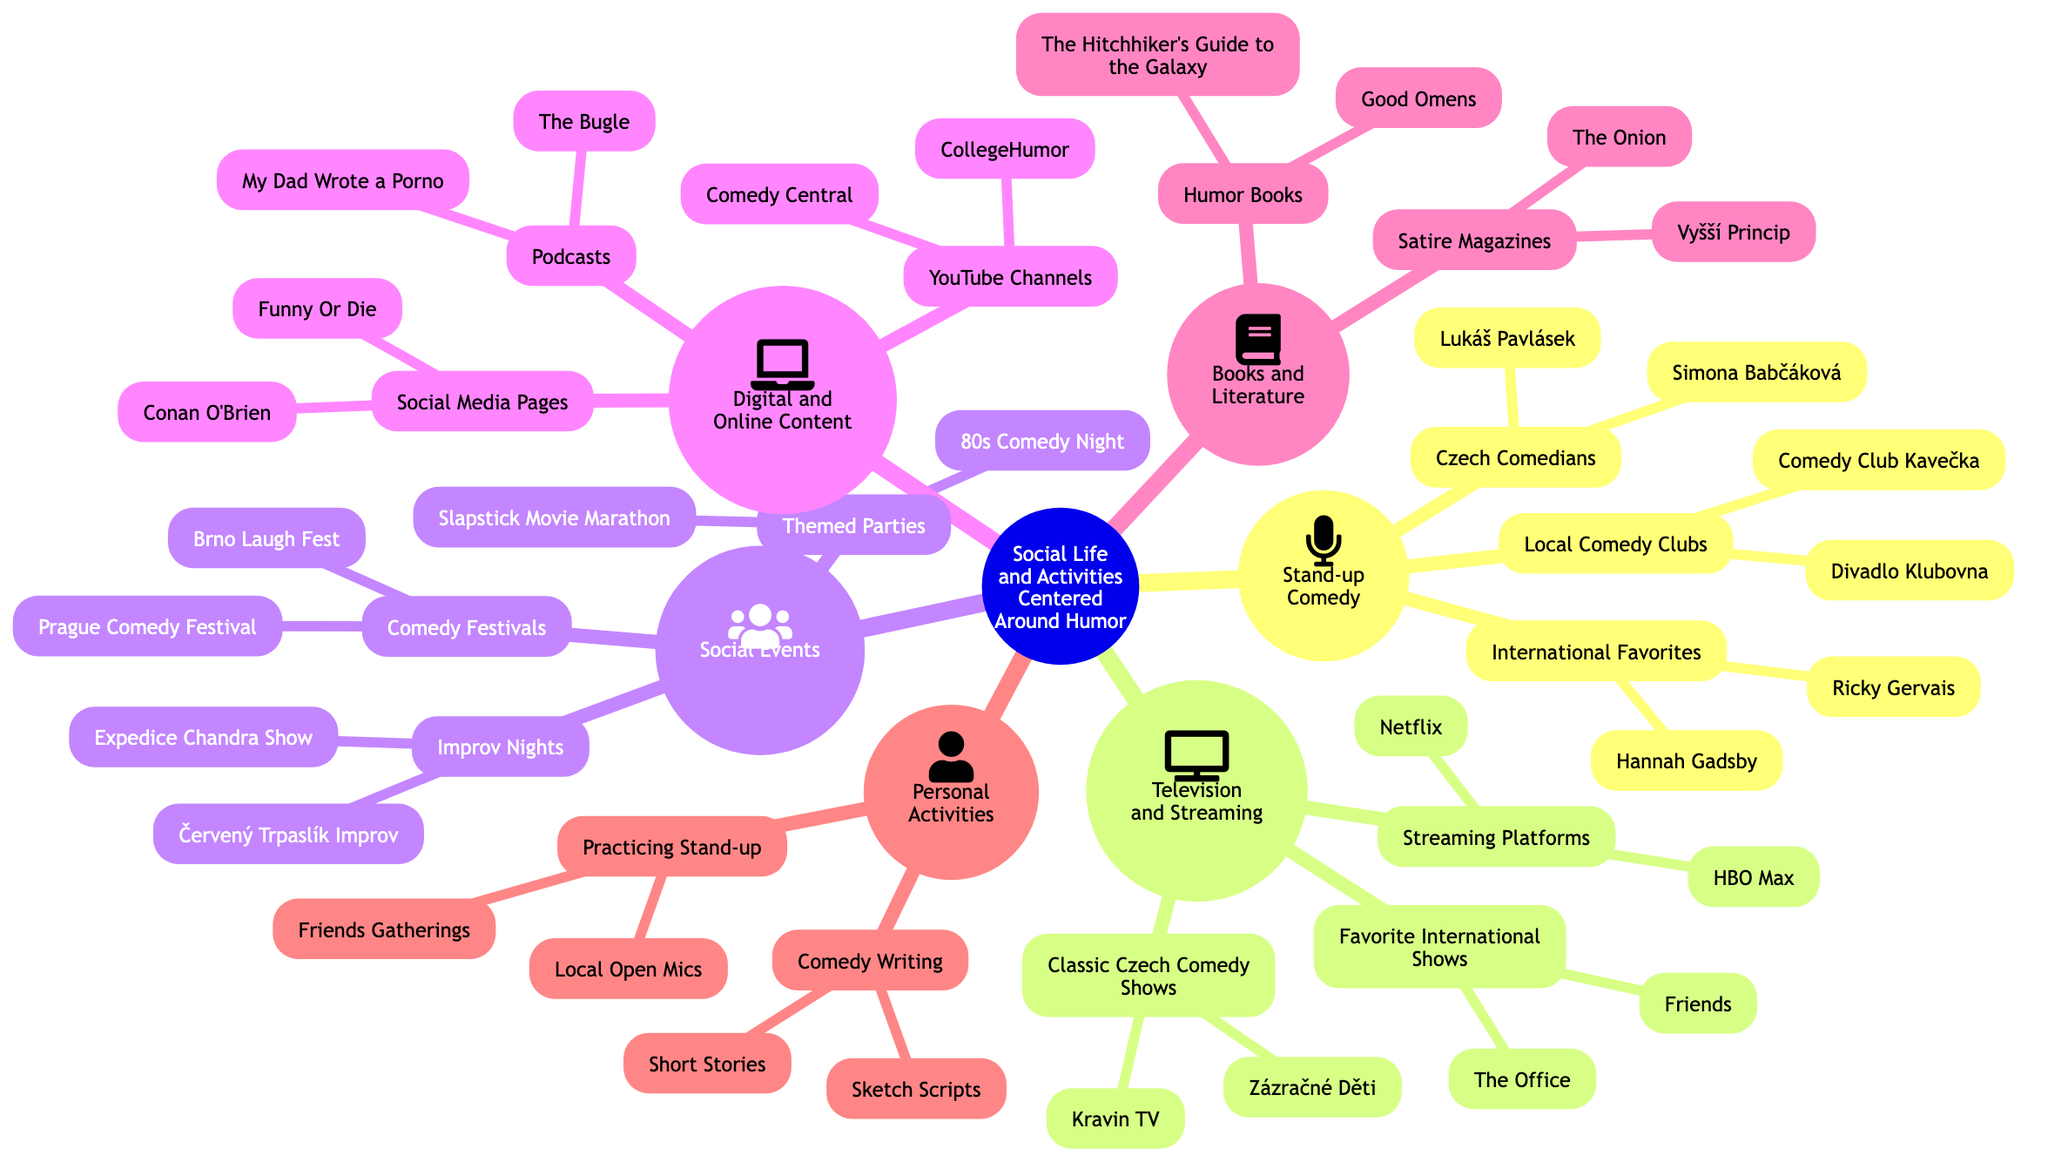What are two local comedy clubs mentioned? The diagram lists "Comedy Club Kavečka" and "Divadlo Klubovna" under the node for Local Comedy Clubs in the Stand-up Comedy section.
Answer: Comedy Club Kavečka, Divadlo Klubovna How many Czech comedians are listed? The node for Czech Comedians contains two names: "Lukáš Pavlásek" and "Simona Babčáková." Hence, the total number is two.
Answer: 2 What is one favorite international comedy show from the diagram? The node under Favorite International Shows includes "Friends" and "The Office." Therefore, one of them can be chosen as an answer.
Answer: Friends What type of events are included in the Social Events category? The Social Events section includes "Comedy Festivals," "Themed Parties," and "Improv Nights," representing various types of social activities centered around humor.
Answer: Comedy Festivals, Themed Parties, Improv Nights Which streaming platform is listed under Television and Streaming? The Streaming Platforms section specifically mentions "Netflix" and "HBO Max." Therefore, any of these would be a correct answer.
Answer: Netflix How many YouTube channels are mentioned? There are two YouTube channels under the Digital and Online Content node: "Comedy Central" and "CollegeHumor." Therefore, the total number is two.
Answer: 2 Which two types of literature are listed in the Books and Literature category? The section for Books and Literature mentions "Humor Books" and "Satire Magazines," indicating these are two distinct types of literary categories associated with humor.
Answer: Humor Books, Satire Magazines What are two activities included in the Personal Activities section? The Personal Activities node details "Practicing Stand-up" and "Comedy Writing" as two different activities related to humor that individuals can engage in.
Answer: Practicing Stand-up, Comedy Writing What festival is held in Prague? Within the Comedy Festivals node, "Prague Comedy Festival" is specifically mentioned as an event that occurs in Prague, representing a key event in the humor-focused social calendar.
Answer: Prague Comedy Festival 